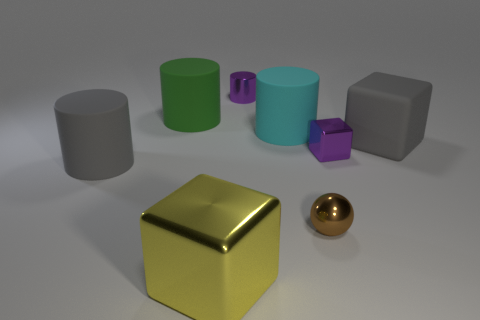How many things are either big rubber cylinders right of the big gray cylinder or small rubber spheres?
Offer a very short reply. 2. Are there any gray objects that have the same size as the yellow metal block?
Keep it short and to the point. Yes. Is the number of big rubber objects less than the number of gray cylinders?
Give a very brief answer. No. What number of spheres are either big yellow shiny objects or big gray things?
Offer a very short reply. 0. What number of metallic blocks are the same color as the small metallic cylinder?
Make the answer very short. 1. How big is the block that is to the left of the big matte block and to the right of the small purple shiny cylinder?
Offer a terse response. Small. Are there fewer small brown metal spheres that are right of the gray block than rubber things?
Your response must be concise. Yes. Is the yellow cube made of the same material as the tiny purple cube?
Ensure brevity in your answer.  Yes. How many things are either large blue blocks or large rubber things?
Make the answer very short. 4. How many green things are made of the same material as the brown sphere?
Your answer should be compact. 0. 